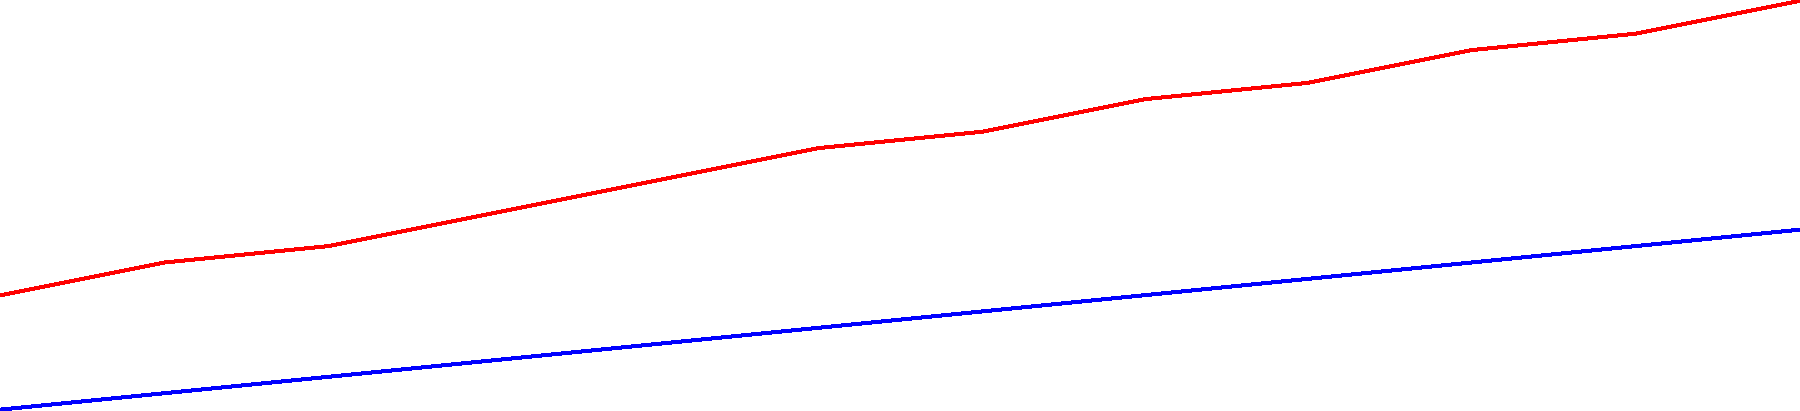Based on the time series chart showing the price trends of flour and sugar over the past year, what is the estimated combined cost per pound of flour and sugar for the upcoming fundraising event in month 13? To estimate the combined cost of flour and sugar for month 13, we need to:

1. Identify the trend for each ingredient:
   - Flour: Increases by about $0.15-$0.20 per month
   - Sugar: Increases by about $0.10 per month

2. Estimate the price for each ingredient in month 13:
   - Flour: Last price (month 12) is $4.30
     Estimated price for month 13: $4.30 + $0.20 = $4.50
   - Sugar: Last price (month 12) is $2.90
     Estimated price for month 13: $2.90 + $0.10 = $3.00

3. Calculate the combined cost:
   $4.50 (flour) + $3.00 (sugar) = $7.50 per pound

Therefore, the estimated combined cost per pound of flour and sugar for the upcoming fundraising event in month 13 is $7.50.
Answer: $7.50 per pound 